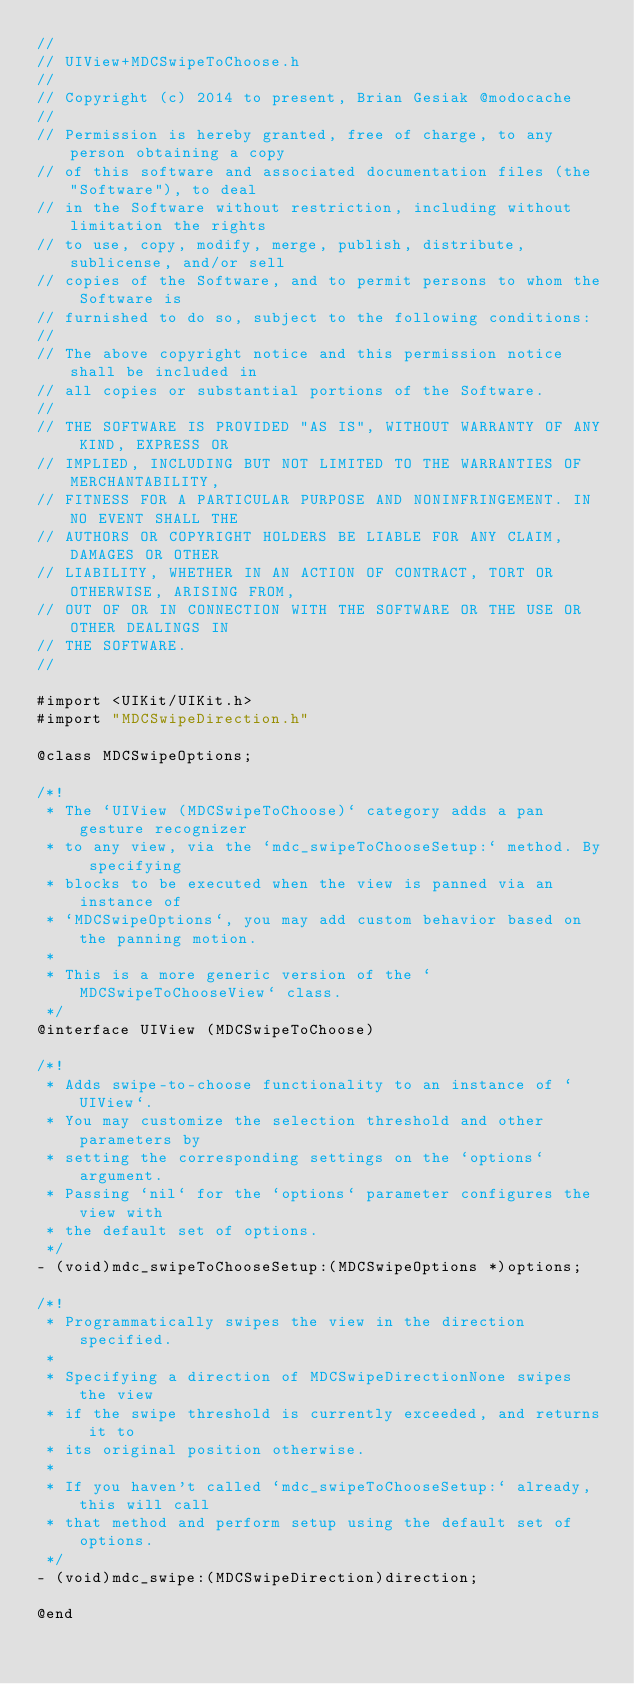Convert code to text. <code><loc_0><loc_0><loc_500><loc_500><_C_>//
// UIView+MDCSwipeToChoose.h
//
// Copyright (c) 2014 to present, Brian Gesiak @modocache
//
// Permission is hereby granted, free of charge, to any person obtaining a copy
// of this software and associated documentation files (the "Software"), to deal
// in the Software without restriction, including without limitation the rights
// to use, copy, modify, merge, publish, distribute, sublicense, and/or sell
// copies of the Software, and to permit persons to whom the Software is
// furnished to do so, subject to the following conditions:
//
// The above copyright notice and this permission notice shall be included in
// all copies or substantial portions of the Software.
//
// THE SOFTWARE IS PROVIDED "AS IS", WITHOUT WARRANTY OF ANY KIND, EXPRESS OR
// IMPLIED, INCLUDING BUT NOT LIMITED TO THE WARRANTIES OF MERCHANTABILITY,
// FITNESS FOR A PARTICULAR PURPOSE AND NONINFRINGEMENT. IN NO EVENT SHALL THE
// AUTHORS OR COPYRIGHT HOLDERS BE LIABLE FOR ANY CLAIM, DAMAGES OR OTHER
// LIABILITY, WHETHER IN AN ACTION OF CONTRACT, TORT OR OTHERWISE, ARISING FROM,
// OUT OF OR IN CONNECTION WITH THE SOFTWARE OR THE USE OR OTHER DEALINGS IN
// THE SOFTWARE.
//

#import <UIKit/UIKit.h>
#import "MDCSwipeDirection.h"

@class MDCSwipeOptions;

/*!
 * The `UIView (MDCSwipeToChoose)` category adds a pan gesture recognizer
 * to any view, via the `mdc_swipeToChooseSetup:` method. By specifying
 * blocks to be executed when the view is panned via an instance of
 * `MDCSwipeOptions`, you may add custom behavior based on the panning motion.
 *
 * This is a more generic version of the `MDCSwipeToChooseView` class.
 */
@interface UIView (MDCSwipeToChoose)

/*!
 * Adds swipe-to-choose functionality to an instance of `UIView`.
 * You may customize the selection threshold and other parameters by
 * setting the corresponding settings on the `options` argument.
 * Passing `nil` for the `options` parameter configures the view with
 * the default set of options.
 */
- (void)mdc_swipeToChooseSetup:(MDCSwipeOptions *)options;

/*!
 * Programmatically swipes the view in the direction specified.
 *
 * Specifying a direction of MDCSwipeDirectionNone swipes the view
 * if the swipe threshold is currently exceeded, and returns it to
 * its original position otherwise.
 *
 * If you haven't called `mdc_swipeToChooseSetup:` already, this will call
 * that method and perform setup using the default set of options.
 */
- (void)mdc_swipe:(MDCSwipeDirection)direction;

@end
</code> 